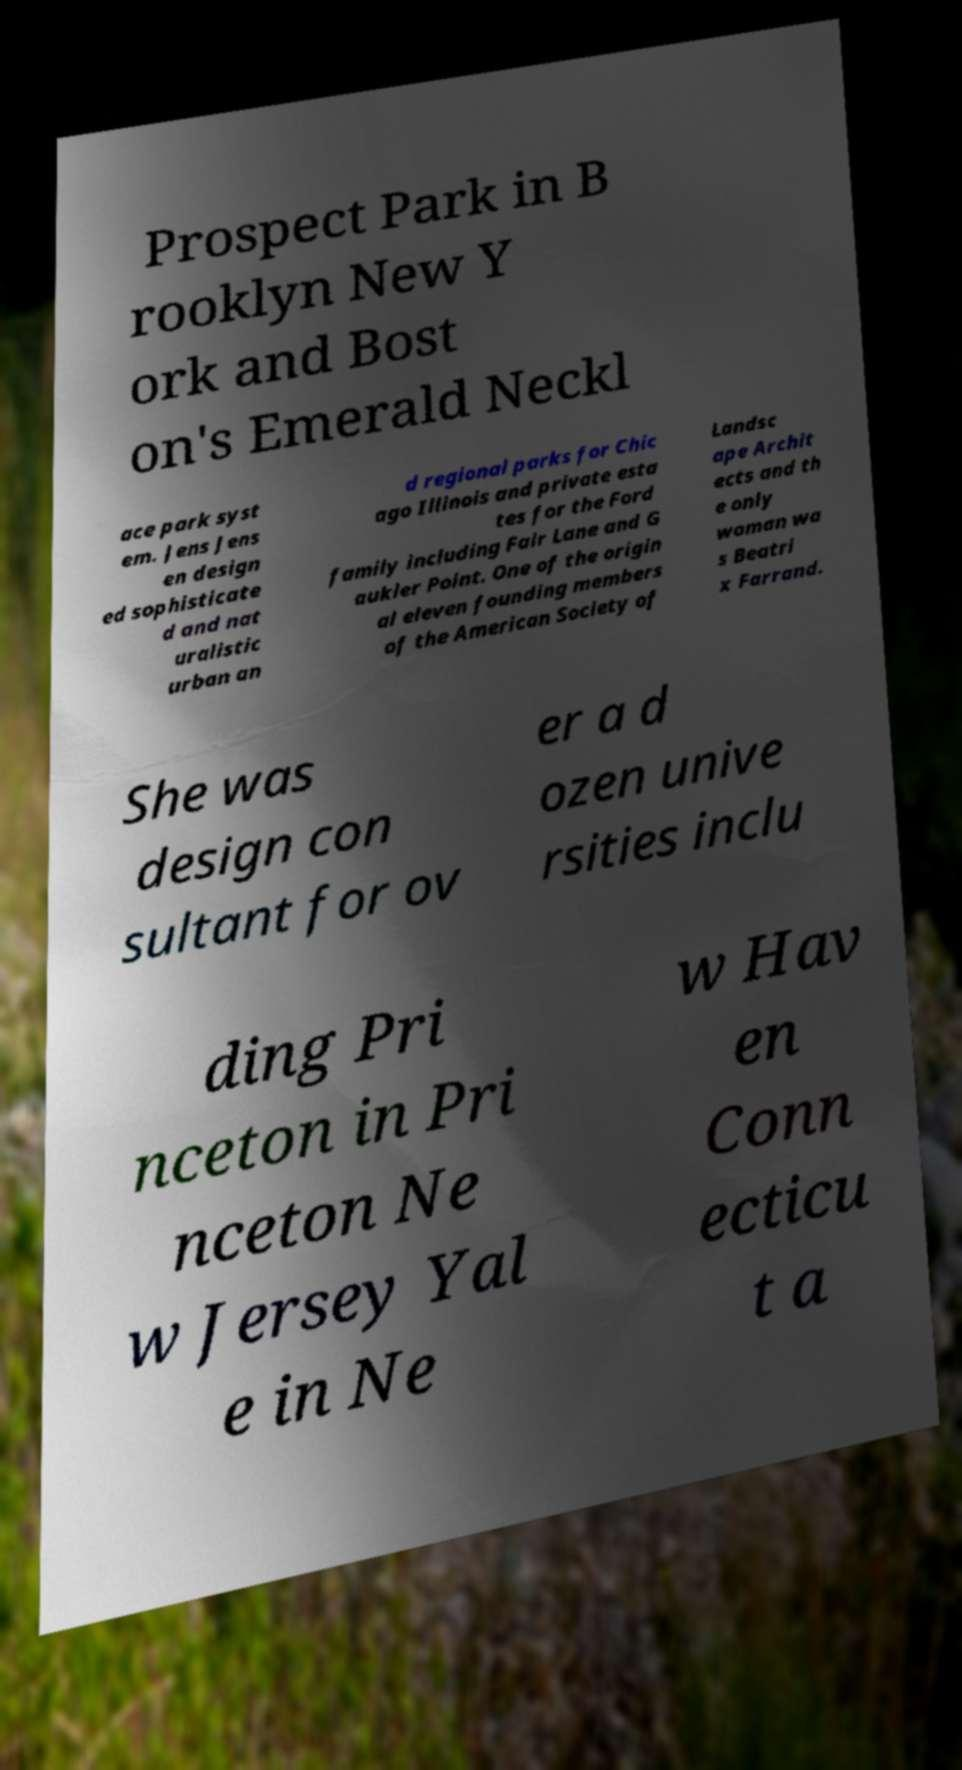Please read and relay the text visible in this image. What does it say? Prospect Park in B rooklyn New Y ork and Bost on's Emerald Neckl ace park syst em. Jens Jens en design ed sophisticate d and nat uralistic urban an d regional parks for Chic ago Illinois and private esta tes for the Ford family including Fair Lane and G aukler Point. One of the origin al eleven founding members of the American Society of Landsc ape Archit ects and th e only woman wa s Beatri x Farrand. She was design con sultant for ov er a d ozen unive rsities inclu ding Pri nceton in Pri nceton Ne w Jersey Yal e in Ne w Hav en Conn ecticu t a 